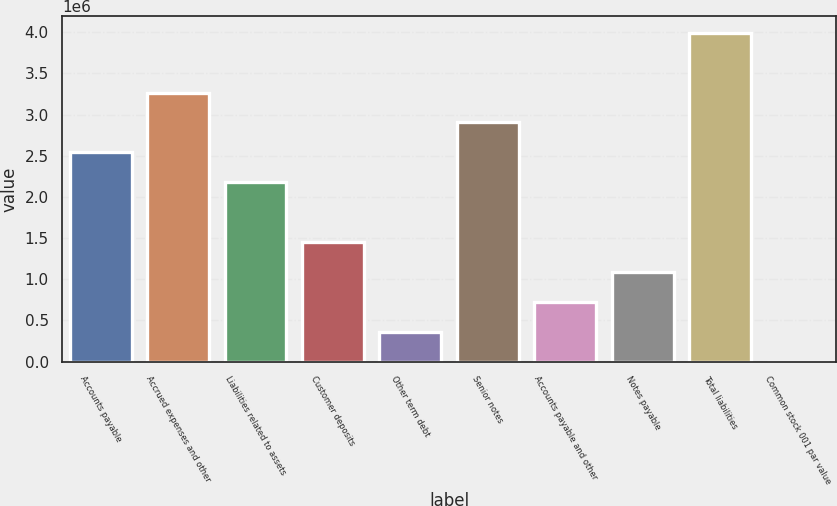Convert chart. <chart><loc_0><loc_0><loc_500><loc_500><bar_chart><fcel>Accounts payable<fcel>Accrued expenses and other<fcel>Liabilities related to assets<fcel>Customer deposits<fcel>Other term debt<fcel>Senior notes<fcel>Accounts payable and other<fcel>Notes payable<fcel>Total liabilities<fcel>Common stock 001 par value<nl><fcel>2.54168e+06<fcel>3.26782e+06<fcel>2.17861e+06<fcel>1.45248e+06<fcel>363274<fcel>2.90475e+06<fcel>726342<fcel>1.08941e+06<fcel>3.99396e+06<fcel>206<nl></chart> 